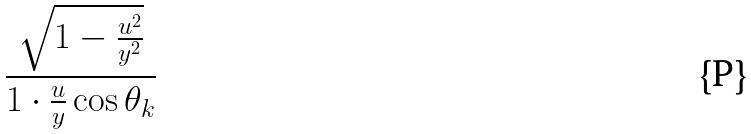<formula> <loc_0><loc_0><loc_500><loc_500>\frac { \sqrt { 1 - \frac { u ^ { 2 } } { y ^ { 2 } } } } { 1 \cdot \frac { u } { y } \cos \theta _ { k } }</formula> 